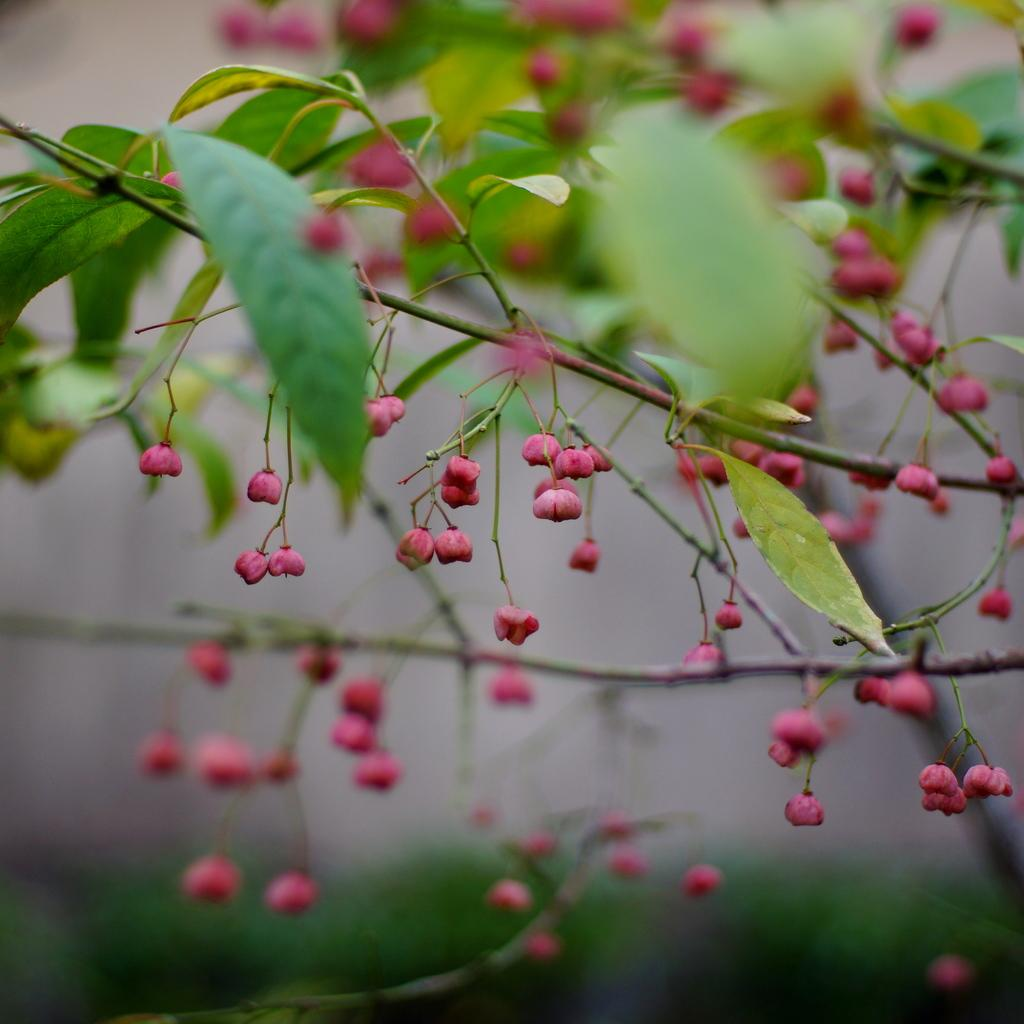What is the main subject of the image? There is a flower plant in the center of the image. Can you describe the flower plant in more detail? Unfortunately, the facts provided do not give any additional details about the flower plant. Is there anything else visible in the image besides the flower plant? The facts provided do not mention any other objects or subjects in the image. What type of account is being discussed in the image? There is no mention of an account in the image, as it only features a flower plant. What type of drink is being served in the image? There is no drink present in the image, as it only features a flower plant. 